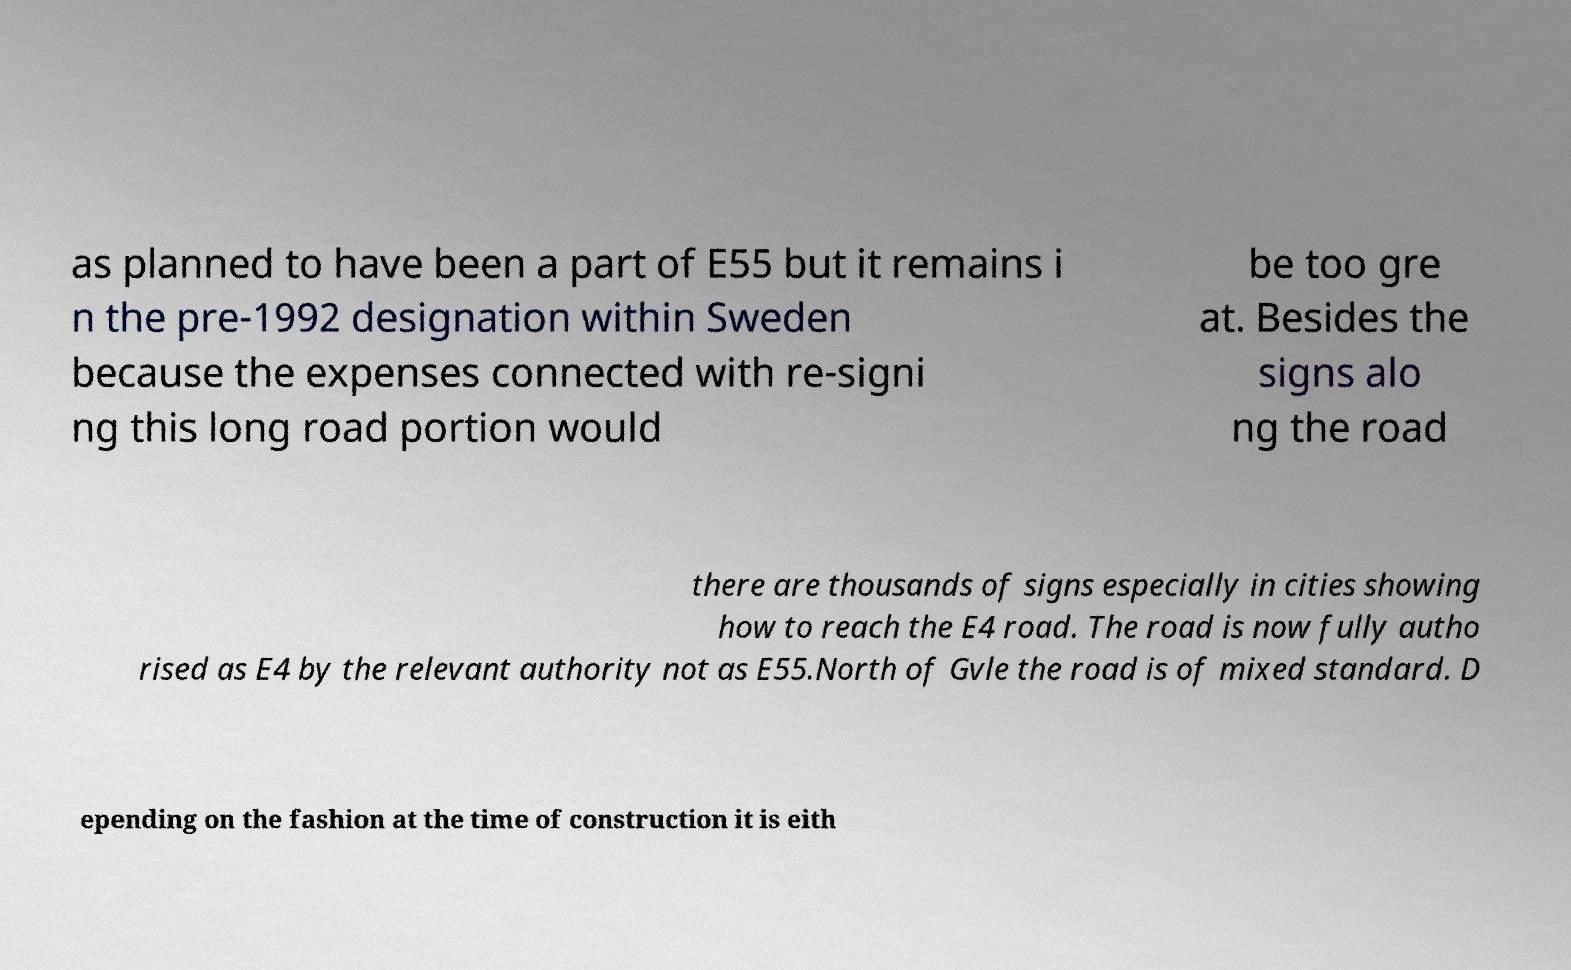I need the written content from this picture converted into text. Can you do that? as planned to have been a part of E55 but it remains i n the pre-1992 designation within Sweden because the expenses connected with re-signi ng this long road portion would be too gre at. Besides the signs alo ng the road there are thousands of signs especially in cities showing how to reach the E4 road. The road is now fully autho rised as E4 by the relevant authority not as E55.North of Gvle the road is of mixed standard. D epending on the fashion at the time of construction it is eith 